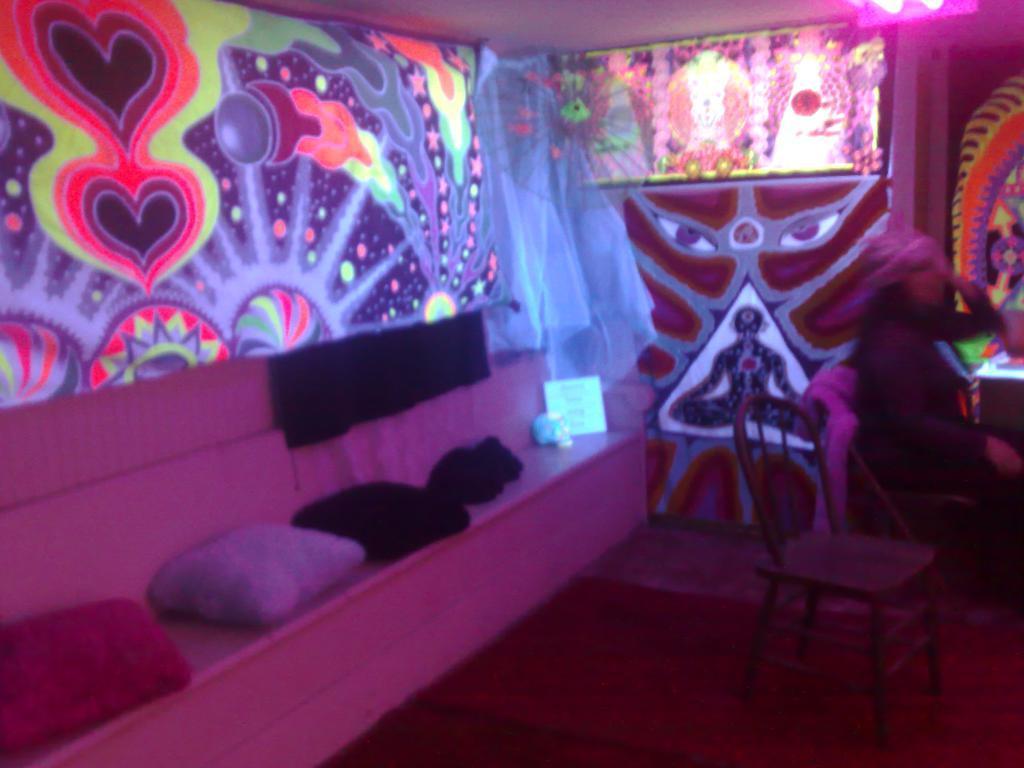Describe this image in one or two sentences. In this image I can see on the left side there are pillows and a different color image. In the middle there are lights, at the right side a woman is sitting on the chair, there is another chair at here. 